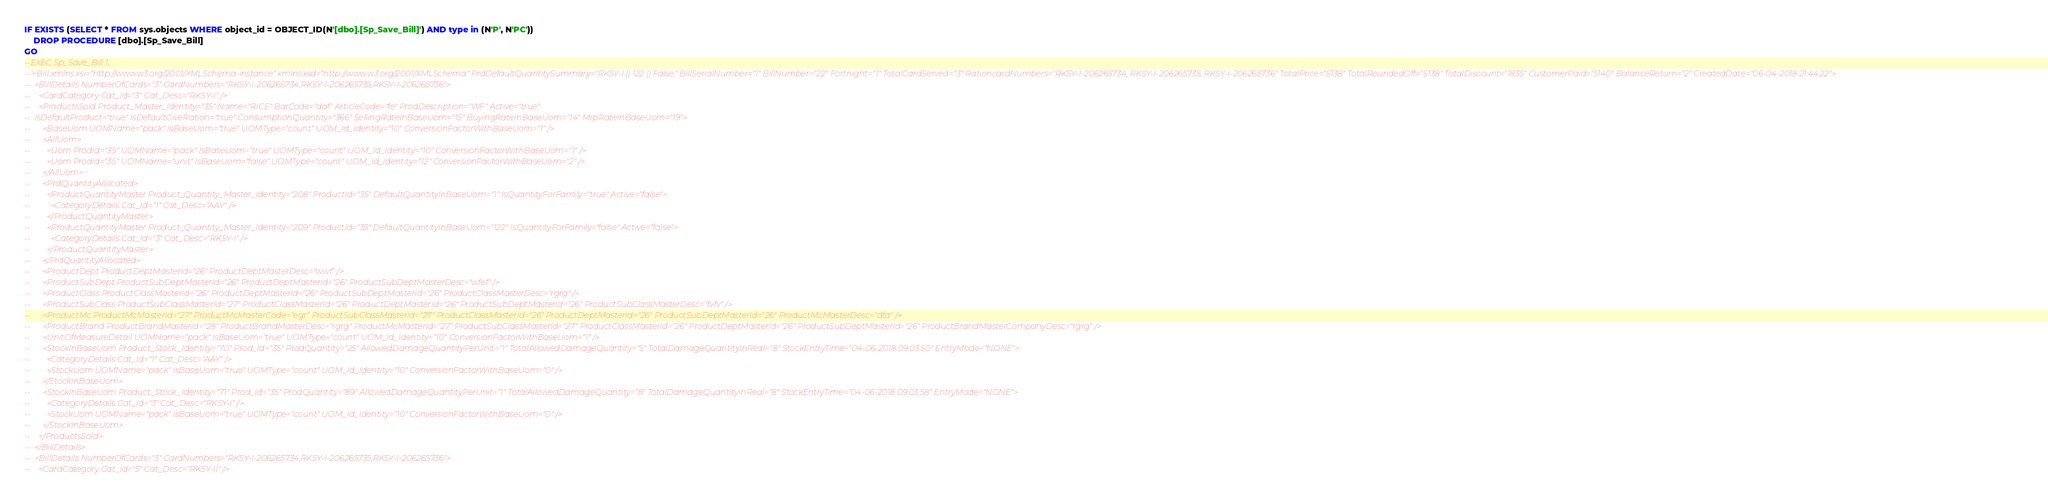Convert code to text. <code><loc_0><loc_0><loc_500><loc_500><_SQL_>IF EXISTS (SELECT * FROM sys.objects WHERE object_id = OBJECT_ID(N'[dbo].[Sp_Save_Bill]') AND type in (N'P', N'PC'))
	DROP PROCEDURE [dbo].[Sp_Save_Bill]
GO
--EXEC Sp_Save_Bill 1, 
--'<Bill xmlns:xsi="http://www.w3.org/2001/XMLSchema-instance" xmlns:xsd="http://www.w3.org/2001/XMLSchema" PrdDefaultQuantitySummary="RKSY-I || 122 || False," BillSerialNumber="1" BillNumber="22" Fortnight="1" TotalCardServed="3" RationcardNumbers="RKSY-I-206265734, RKSY-I-206265735, RKSY-I-206265736" TotalPrice="5138" TotalRoundedOff="5138" TotalDiscount="1835" CustomerPaid="5140" BalanceReturn="2" CreatedDate="06-04-2018 21:44:22">
--  <BillDetails NumberOfCards="3" CardNumbers="RKSY-I-206265734,RKSY-I-206265735,RKSY-I-206265736">
--    <CardCategory Cat_Id="3" Cat_Desc="RKSY-I" />
--    <ProductsSold Product_Master_Identity="35" Name="RICE" BarCode="daf" ArticleCode="fe" ProdDescription="WF" Active="true" 
--	IsDefaultProduct="true" IsDefaultGiveRation="true" ConsumptionQuantity="366" SellingRateInBaseUom="15" BuyingRateInBaseUom="14" MrpRateInBaseUom="19">
--      <BaseUom UOMName="pack" IsBaseUom="true" UOMType="count" UOM_Id_Identity="10" ConversionFactorWithBaseUom="1" />
--      <AllUom>
--        <Uom ProdId="35" UOMName="pack" IsBaseUom="true" UOMType="count" UOM_Id_Identity="10" ConversionFactorWithBaseUom="1" />
--        <Uom ProdId="35" UOMName="unit" IsBaseUom="false" UOMType="count" UOM_Id_Identity="12" ConversionFactorWithBaseUom="2" />
--      </AllUom>
--      <PrdQuantityAllocated>
--        <ProductQuantityMaster Product_Quantity_Master_Identity="208" ProductId="35" DefaultQuantityInBaseUom="1" IsQuantityForFamily="true" Active="false">
--          <CategoryDetails Cat_Id="1" Cat_Desc="AAY" />
--        </ProductQuantityMaster>
--        <ProductQuantityMaster Product_Quantity_Master_Identity="209" ProductId="35" DefaultQuantityInBaseUom="122" IsQuantityForFamily="false" Active="false">
--          <CategoryDetails Cat_Id="3" Cat_Desc="RKSY-I" />
--        </ProductQuantityMaster>
--      </PrdQuantityAllocated>
--      <ProductDept ProductDeptMasterId="26" ProductDeptMasterDesc="wwf" />
--      <ProductSubDept ProductSubDeptMasterId="26" ProductDeptMasterId="26" ProductSubDeptMasterDesc="wfef" />
--      <ProductClass ProductClassMasterId="26" ProductDeptMasterId="26" ProductSubDeptMasterId="26" ProductClassMasterDesc="rgrg" />
--      <ProductSubClass ProductSubClassMasterId="27" ProductClassMasterId="26" ProductDeptMasterId="26" ProductSubDeptMasterId="26" ProductSubClassMasterDesc="fvfv" />
--      <ProductMc ProductMcMasterId="27" ProductMcMasterCode="egr" ProductSubClassMasterId="27" ProductClassMasterId="26" ProductDeptMasterId="26" ProductSubDeptMasterId="26" ProductMcMasterDesc="dfa" />
--      <ProductBrand ProductBrandMasterId="28" ProductBrandMasterDesc="rgrg" ProductMcMasterId="27" ProductSubClassMasterId="27" ProductClassMasterId="26" ProductDeptMasterId="26" ProductSubDeptMasterId="26" ProductBrandMasterCompanyDesc="rgrg" />
--      <UnitOfMeasureDetail UOMName="pack" IsBaseUom="true" UOMType="count" UOM_Id_Identity="10" ConversionFactorWithBaseUom="1" />
--      <StockInBaseUom Product_Stock_Identity="70" Prod_Id="35" ProdQuantity="25" AllowedDamageQuantityPerUnit="1" TotalAllowedDamageQuantity="5" TotalDamageQuantityInReal="8" StockEntryTime="04-06-2018 09:03:50" EntryMode="NONE">
--        <CategoryDetails Cat_Id="1" Cat_Desc="AAY" />
--        <StockUom UOMName="pack" IsBaseUom="true" UOMType="count" UOM_Id_Identity="10" ConversionFactorWithBaseUom="0" />
--      </StockInBaseUom>
--      <StockInBaseUom Product_Stock_Identity="71" Prod_Id="35" ProdQuantity="89" AllowedDamageQuantityPerUnit="1" TotalAllowedDamageQuantity="8" TotalDamageQuantityInReal="8" StockEntryTime="04-06-2018 09:03:58" EntryMode="NONE">
--        <CategoryDetails Cat_Id="3" Cat_Desc="RKSY-I" />
--        <StockUom UOMName="pack" IsBaseUom="true" UOMType="count" UOM_Id_Identity="10" ConversionFactorWithBaseUom="0" />
--      </StockInBaseUom>
--    </ProductsSold>
--  </BillDetails>
--  <BillDetails NumberOfCards="3" CardNumbers="RKSY-I-206265734,RKSY-I-206265735,RKSY-I-206265736">
--    <CardCategory Cat_Id="5" Cat_Desc="RKSY-II" /></code> 